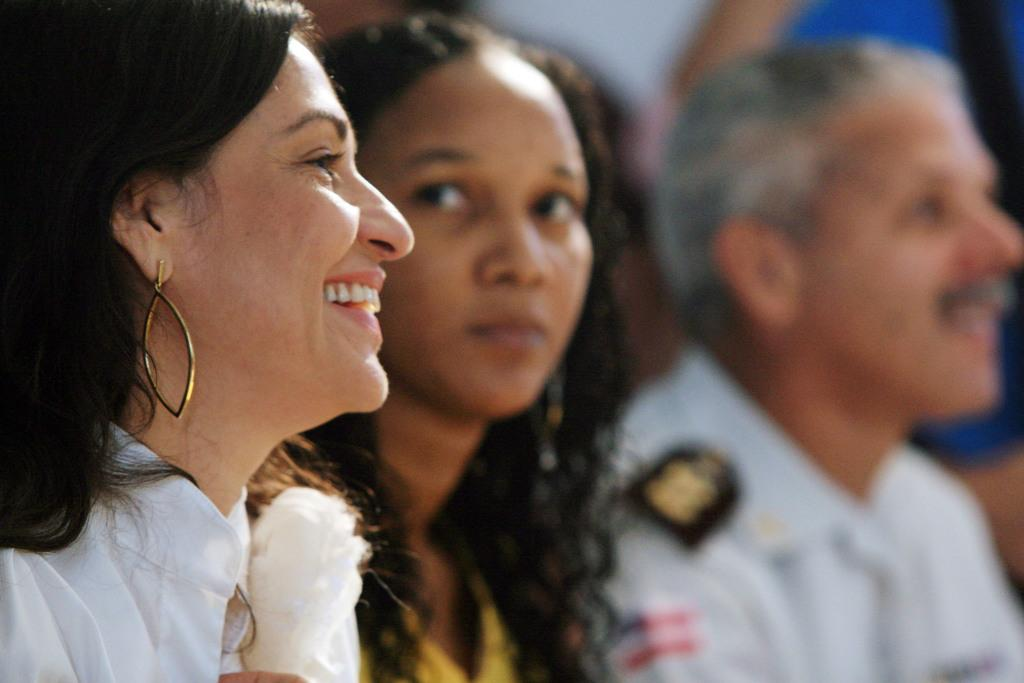Who is on the left side of the image? There is a woman on the left side of the image. What is the woman doing in the image? The woman is smiling in the image. How many people are in the image? There are two persons in the image. Can you describe the background of the image? The background of the image is blurred. What type of potato is being used as a prop in the image? There is no potato present in the image. Can you describe the door in the image? There is no door present in the image. 